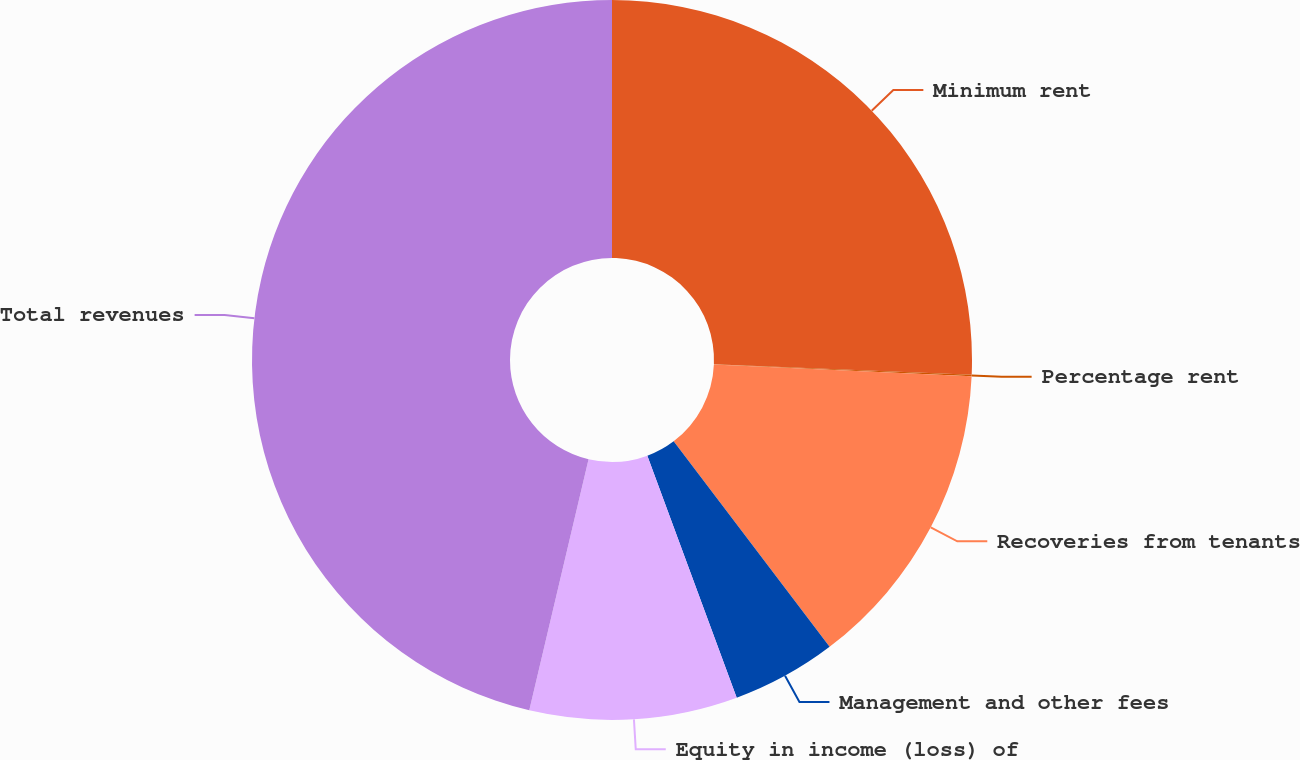<chart> <loc_0><loc_0><loc_500><loc_500><pie_chart><fcel>Minimum rent<fcel>Percentage rent<fcel>Recoveries from tenants<fcel>Management and other fees<fcel>Equity in income (loss) of<fcel>Total revenues<nl><fcel>25.65%<fcel>0.07%<fcel>13.95%<fcel>4.7%<fcel>9.32%<fcel>46.31%<nl></chart> 